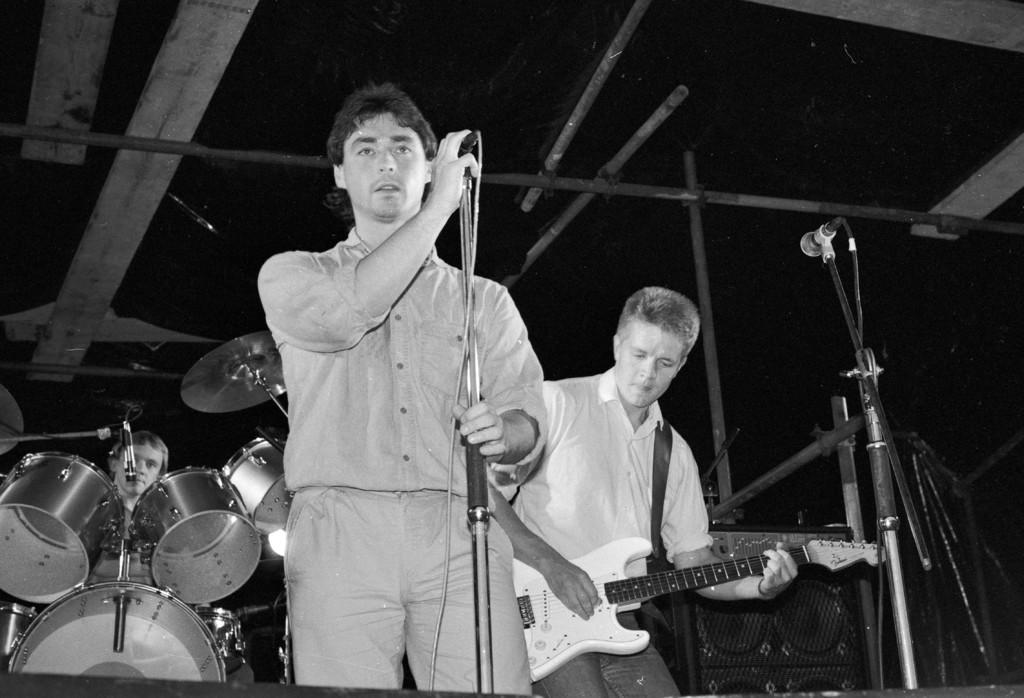What is the color scheme of the image? The image is black and white. How many people are in the image? There are three persons in the image. What is the first person holding? The first person is holding a mic. What instrument is the second person playing? The second person is playing a guitar. What is the third person doing in the image? The third person is playing the drums. Can you see any birds flying in the image? There are no birds visible in the image. What type of feather is the third person using to play the drums? There is no feather present in the image, and the third person is playing the drums with drumsticks, not a feather. 